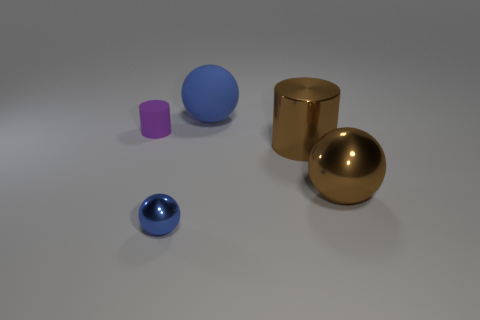Add 4 large balls. How many objects exist? 9 Subtract all cylinders. How many objects are left? 3 Add 4 small yellow spheres. How many small yellow spheres exist? 4 Subtract 0 gray spheres. How many objects are left? 5 Subtract all big gray blocks. Subtract all brown cylinders. How many objects are left? 4 Add 4 big objects. How many big objects are left? 7 